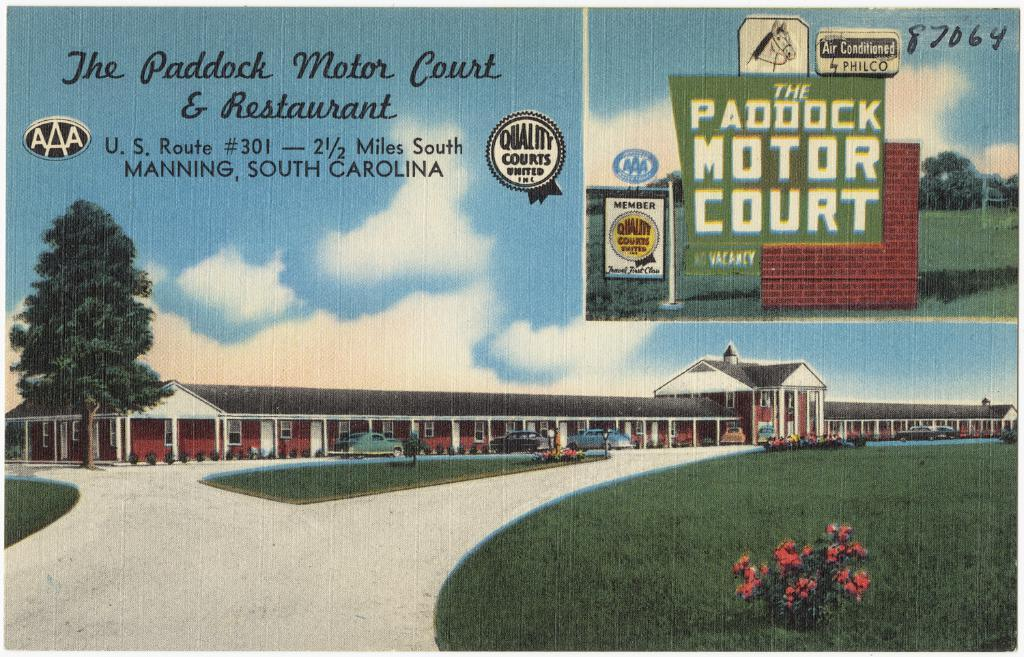<image>
Give a short and clear explanation of the subsequent image. A postcard for the Paddock Motor Court in South Carolina. 